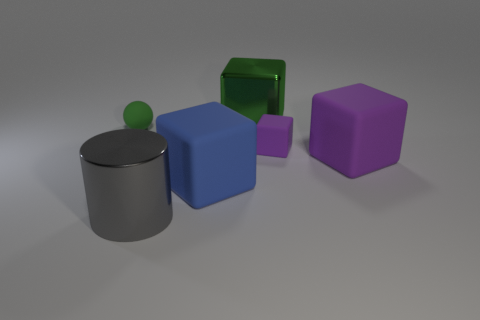Subtract all blue cubes. How many cubes are left? 3 Subtract all cylinders. How many objects are left? 5 Subtract all blue cylinders. How many purple cubes are left? 2 Add 3 cylinders. How many objects exist? 9 Subtract all purple blocks. How many blocks are left? 2 Subtract 1 balls. How many balls are left? 0 Add 2 purple rubber blocks. How many purple rubber blocks exist? 4 Subtract 0 cyan cylinders. How many objects are left? 6 Subtract all blue cylinders. Subtract all blue balls. How many cylinders are left? 1 Subtract all big objects. Subtract all tiny purple things. How many objects are left? 1 